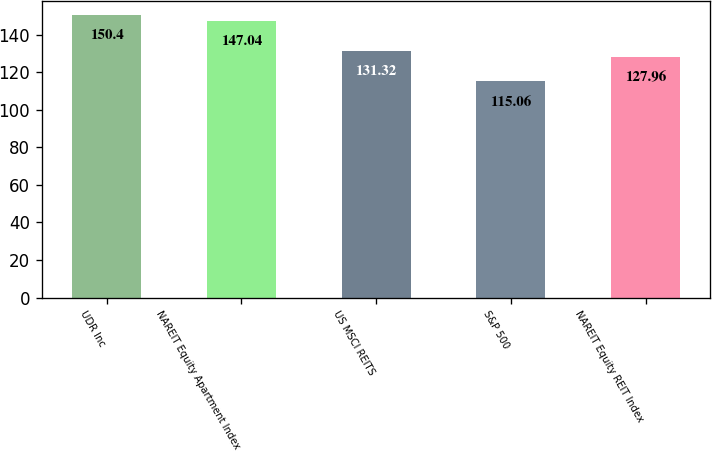Convert chart to OTSL. <chart><loc_0><loc_0><loc_500><loc_500><bar_chart><fcel>UDR Inc<fcel>NAREIT Equity Apartment Index<fcel>US MSCI REITS<fcel>S&P 500<fcel>NAREIT Equity REIT Index<nl><fcel>150.4<fcel>147.04<fcel>131.32<fcel>115.06<fcel>127.96<nl></chart> 